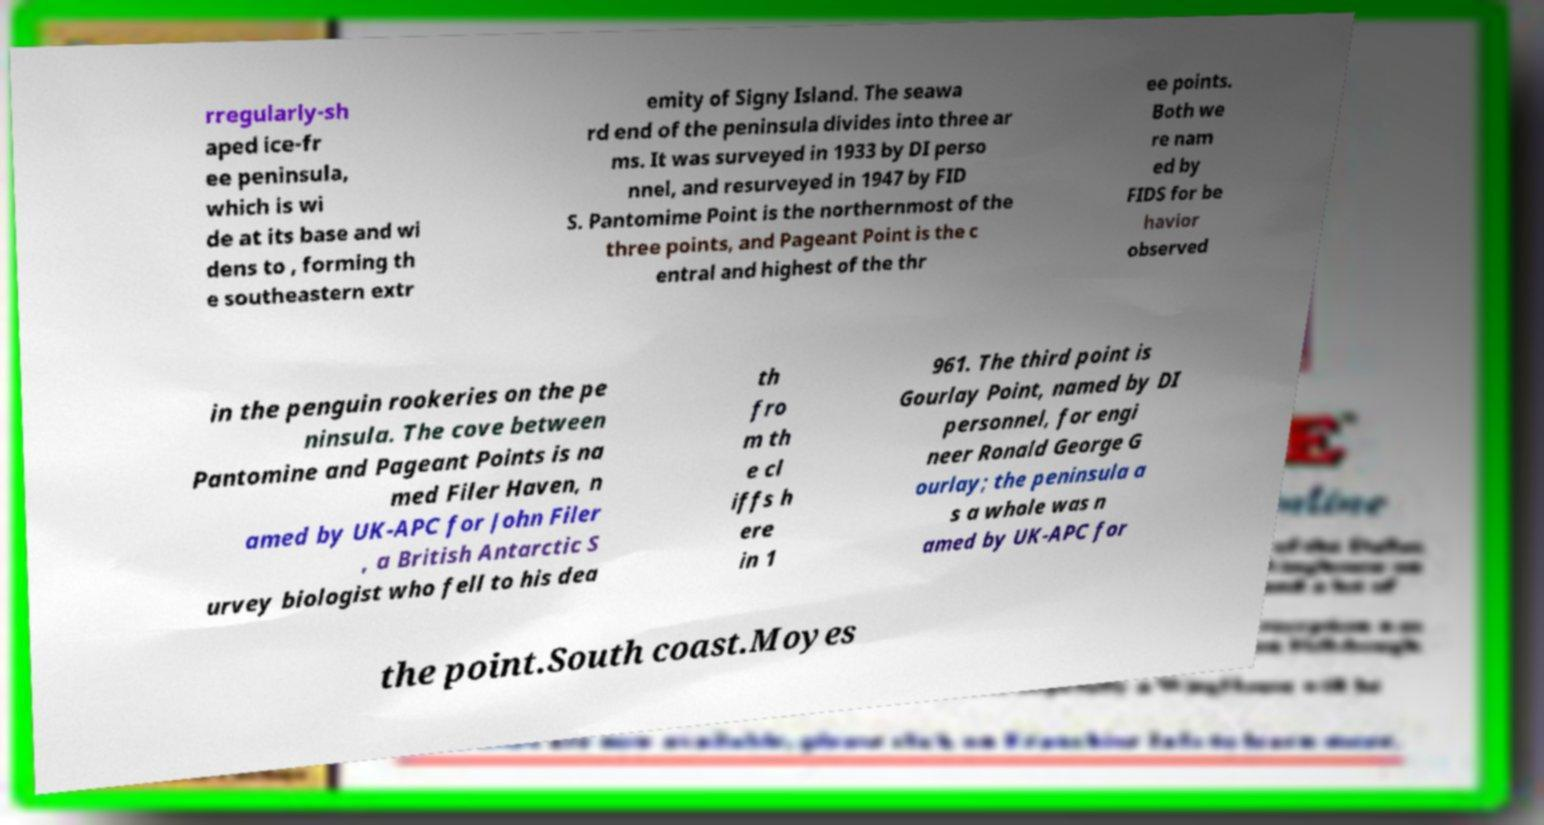Could you extract and type out the text from this image? rregularly-sh aped ice-fr ee peninsula, which is wi de at its base and wi dens to , forming th e southeastern extr emity of Signy Island. The seawa rd end of the peninsula divides into three ar ms. It was surveyed in 1933 by DI perso nnel, and resurveyed in 1947 by FID S. Pantomime Point is the northernmost of the three points, and Pageant Point is the c entral and highest of the thr ee points. Both we re nam ed by FIDS for be havior observed in the penguin rookeries on the pe ninsula. The cove between Pantomine and Pageant Points is na med Filer Haven, n amed by UK-APC for John Filer , a British Antarctic S urvey biologist who fell to his dea th fro m th e cl iffs h ere in 1 961. The third point is Gourlay Point, named by DI personnel, for engi neer Ronald George G ourlay; the peninsula a s a whole was n amed by UK-APC for the point.South coast.Moyes 